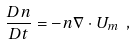Convert formula to latex. <formula><loc_0><loc_0><loc_500><loc_500>\frac { D n } { D t } = - n \nabla \cdot U _ { m } \ ,</formula> 